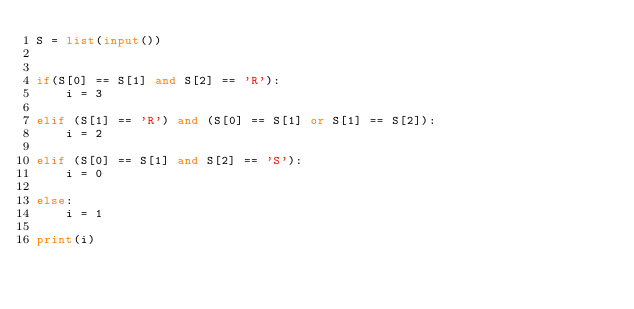<code> <loc_0><loc_0><loc_500><loc_500><_Python_>S = list(input())


if(S[0] == S[1] and S[2] == 'R'):
    i = 3

elif (S[1] == 'R') and (S[0] == S[1] or S[1] == S[2]):
    i = 2

elif (S[0] == S[1] and S[2] == 'S'):
    i = 0

else:
    i = 1

print(i)</code> 